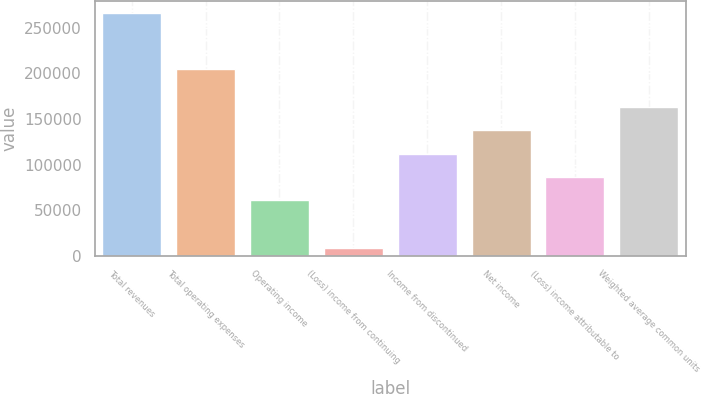<chart> <loc_0><loc_0><loc_500><loc_500><bar_chart><fcel>Total revenues<fcel>Total operating expenses<fcel>Operating income<fcel>(Loss) income from continuing<fcel>Income from discontinued<fcel>Net income<fcel>(Loss) income attributable to<fcel>Weighted average common units<nl><fcel>265995<fcel>205138<fcel>60857<fcel>9060<fcel>112244<fcel>137938<fcel>86550.5<fcel>163631<nl></chart> 